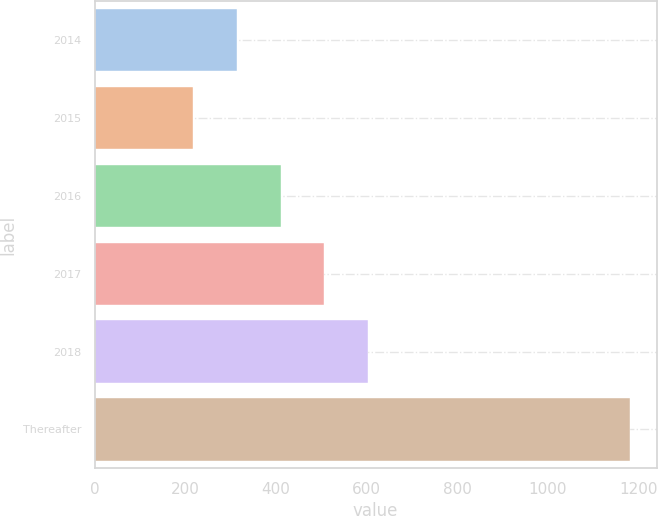<chart> <loc_0><loc_0><loc_500><loc_500><bar_chart><fcel>2014<fcel>2015<fcel>2016<fcel>2017<fcel>2018<fcel>Thereafter<nl><fcel>314.3<fcel>218<fcel>410.6<fcel>506.9<fcel>603.2<fcel>1181<nl></chart> 